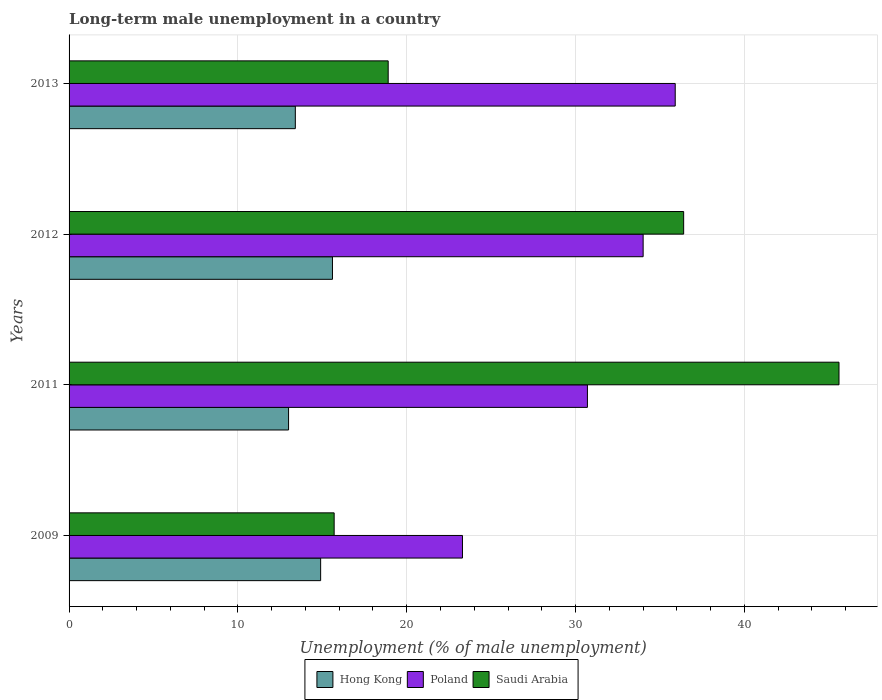How many groups of bars are there?
Your answer should be compact. 4. How many bars are there on the 2nd tick from the top?
Provide a succinct answer. 3. How many bars are there on the 3rd tick from the bottom?
Your response must be concise. 3. What is the label of the 2nd group of bars from the top?
Provide a succinct answer. 2012. In how many cases, is the number of bars for a given year not equal to the number of legend labels?
Your answer should be very brief. 0. What is the percentage of long-term unemployed male population in Poland in 2012?
Give a very brief answer. 34. Across all years, what is the maximum percentage of long-term unemployed male population in Poland?
Offer a very short reply. 35.9. Across all years, what is the minimum percentage of long-term unemployed male population in Poland?
Your answer should be compact. 23.3. In which year was the percentage of long-term unemployed male population in Saudi Arabia maximum?
Provide a short and direct response. 2011. What is the total percentage of long-term unemployed male population in Poland in the graph?
Your answer should be very brief. 123.9. What is the difference between the percentage of long-term unemployed male population in Hong Kong in 2009 and that in 2012?
Your response must be concise. -0.7. What is the difference between the percentage of long-term unemployed male population in Poland in 2009 and the percentage of long-term unemployed male population in Hong Kong in 2012?
Provide a short and direct response. 7.7. What is the average percentage of long-term unemployed male population in Poland per year?
Your answer should be compact. 30.98. In the year 2013, what is the difference between the percentage of long-term unemployed male population in Saudi Arabia and percentage of long-term unemployed male population in Poland?
Offer a very short reply. -17. In how many years, is the percentage of long-term unemployed male population in Poland greater than 6 %?
Offer a very short reply. 4. What is the ratio of the percentage of long-term unemployed male population in Saudi Arabia in 2009 to that in 2013?
Offer a terse response. 0.83. Is the percentage of long-term unemployed male population in Hong Kong in 2011 less than that in 2013?
Give a very brief answer. Yes. What is the difference between the highest and the second highest percentage of long-term unemployed male population in Saudi Arabia?
Keep it short and to the point. 9.2. What is the difference between the highest and the lowest percentage of long-term unemployed male population in Hong Kong?
Provide a short and direct response. 2.6. In how many years, is the percentage of long-term unemployed male population in Poland greater than the average percentage of long-term unemployed male population in Poland taken over all years?
Offer a terse response. 2. Is the sum of the percentage of long-term unemployed male population in Poland in 2009 and 2012 greater than the maximum percentage of long-term unemployed male population in Hong Kong across all years?
Your answer should be very brief. Yes. What does the 1st bar from the bottom in 2009 represents?
Offer a very short reply. Hong Kong. Is it the case that in every year, the sum of the percentage of long-term unemployed male population in Poland and percentage of long-term unemployed male population in Saudi Arabia is greater than the percentage of long-term unemployed male population in Hong Kong?
Offer a very short reply. Yes. How many years are there in the graph?
Offer a terse response. 4. How many legend labels are there?
Your response must be concise. 3. How are the legend labels stacked?
Provide a succinct answer. Horizontal. What is the title of the graph?
Keep it short and to the point. Long-term male unemployment in a country. What is the label or title of the X-axis?
Offer a terse response. Unemployment (% of male unemployment). What is the Unemployment (% of male unemployment) in Hong Kong in 2009?
Your answer should be very brief. 14.9. What is the Unemployment (% of male unemployment) in Poland in 2009?
Offer a terse response. 23.3. What is the Unemployment (% of male unemployment) of Saudi Arabia in 2009?
Your answer should be compact. 15.7. What is the Unemployment (% of male unemployment) in Poland in 2011?
Make the answer very short. 30.7. What is the Unemployment (% of male unemployment) of Saudi Arabia in 2011?
Your response must be concise. 45.6. What is the Unemployment (% of male unemployment) of Hong Kong in 2012?
Your response must be concise. 15.6. What is the Unemployment (% of male unemployment) of Saudi Arabia in 2012?
Make the answer very short. 36.4. What is the Unemployment (% of male unemployment) of Hong Kong in 2013?
Ensure brevity in your answer.  13.4. What is the Unemployment (% of male unemployment) in Poland in 2013?
Provide a short and direct response. 35.9. What is the Unemployment (% of male unemployment) in Saudi Arabia in 2013?
Your response must be concise. 18.9. Across all years, what is the maximum Unemployment (% of male unemployment) in Hong Kong?
Your answer should be compact. 15.6. Across all years, what is the maximum Unemployment (% of male unemployment) of Poland?
Provide a short and direct response. 35.9. Across all years, what is the maximum Unemployment (% of male unemployment) in Saudi Arabia?
Offer a terse response. 45.6. Across all years, what is the minimum Unemployment (% of male unemployment) in Hong Kong?
Your answer should be very brief. 13. Across all years, what is the minimum Unemployment (% of male unemployment) in Poland?
Your answer should be very brief. 23.3. Across all years, what is the minimum Unemployment (% of male unemployment) of Saudi Arabia?
Keep it short and to the point. 15.7. What is the total Unemployment (% of male unemployment) of Hong Kong in the graph?
Your response must be concise. 56.9. What is the total Unemployment (% of male unemployment) of Poland in the graph?
Your response must be concise. 123.9. What is the total Unemployment (% of male unemployment) in Saudi Arabia in the graph?
Your answer should be very brief. 116.6. What is the difference between the Unemployment (% of male unemployment) of Hong Kong in 2009 and that in 2011?
Give a very brief answer. 1.9. What is the difference between the Unemployment (% of male unemployment) in Poland in 2009 and that in 2011?
Provide a succinct answer. -7.4. What is the difference between the Unemployment (% of male unemployment) of Saudi Arabia in 2009 and that in 2011?
Offer a very short reply. -29.9. What is the difference between the Unemployment (% of male unemployment) in Hong Kong in 2009 and that in 2012?
Provide a succinct answer. -0.7. What is the difference between the Unemployment (% of male unemployment) in Poland in 2009 and that in 2012?
Offer a terse response. -10.7. What is the difference between the Unemployment (% of male unemployment) in Saudi Arabia in 2009 and that in 2012?
Offer a terse response. -20.7. What is the difference between the Unemployment (% of male unemployment) of Hong Kong in 2011 and that in 2012?
Offer a very short reply. -2.6. What is the difference between the Unemployment (% of male unemployment) of Saudi Arabia in 2011 and that in 2012?
Make the answer very short. 9.2. What is the difference between the Unemployment (% of male unemployment) of Saudi Arabia in 2011 and that in 2013?
Provide a short and direct response. 26.7. What is the difference between the Unemployment (% of male unemployment) in Hong Kong in 2012 and that in 2013?
Offer a terse response. 2.2. What is the difference between the Unemployment (% of male unemployment) in Poland in 2012 and that in 2013?
Keep it short and to the point. -1.9. What is the difference between the Unemployment (% of male unemployment) in Saudi Arabia in 2012 and that in 2013?
Your answer should be very brief. 17.5. What is the difference between the Unemployment (% of male unemployment) in Hong Kong in 2009 and the Unemployment (% of male unemployment) in Poland in 2011?
Give a very brief answer. -15.8. What is the difference between the Unemployment (% of male unemployment) in Hong Kong in 2009 and the Unemployment (% of male unemployment) in Saudi Arabia in 2011?
Offer a very short reply. -30.7. What is the difference between the Unemployment (% of male unemployment) in Poland in 2009 and the Unemployment (% of male unemployment) in Saudi Arabia in 2011?
Provide a short and direct response. -22.3. What is the difference between the Unemployment (% of male unemployment) of Hong Kong in 2009 and the Unemployment (% of male unemployment) of Poland in 2012?
Make the answer very short. -19.1. What is the difference between the Unemployment (% of male unemployment) in Hong Kong in 2009 and the Unemployment (% of male unemployment) in Saudi Arabia in 2012?
Provide a short and direct response. -21.5. What is the difference between the Unemployment (% of male unemployment) in Poland in 2009 and the Unemployment (% of male unemployment) in Saudi Arabia in 2012?
Offer a very short reply. -13.1. What is the difference between the Unemployment (% of male unemployment) in Hong Kong in 2009 and the Unemployment (% of male unemployment) in Poland in 2013?
Make the answer very short. -21. What is the difference between the Unemployment (% of male unemployment) of Hong Kong in 2009 and the Unemployment (% of male unemployment) of Saudi Arabia in 2013?
Provide a short and direct response. -4. What is the difference between the Unemployment (% of male unemployment) in Hong Kong in 2011 and the Unemployment (% of male unemployment) in Poland in 2012?
Provide a short and direct response. -21. What is the difference between the Unemployment (% of male unemployment) in Hong Kong in 2011 and the Unemployment (% of male unemployment) in Saudi Arabia in 2012?
Keep it short and to the point. -23.4. What is the difference between the Unemployment (% of male unemployment) in Hong Kong in 2011 and the Unemployment (% of male unemployment) in Poland in 2013?
Provide a short and direct response. -22.9. What is the difference between the Unemployment (% of male unemployment) of Hong Kong in 2011 and the Unemployment (% of male unemployment) of Saudi Arabia in 2013?
Keep it short and to the point. -5.9. What is the difference between the Unemployment (% of male unemployment) of Hong Kong in 2012 and the Unemployment (% of male unemployment) of Poland in 2013?
Offer a very short reply. -20.3. What is the difference between the Unemployment (% of male unemployment) of Hong Kong in 2012 and the Unemployment (% of male unemployment) of Saudi Arabia in 2013?
Your answer should be compact. -3.3. What is the difference between the Unemployment (% of male unemployment) in Poland in 2012 and the Unemployment (% of male unemployment) in Saudi Arabia in 2013?
Make the answer very short. 15.1. What is the average Unemployment (% of male unemployment) of Hong Kong per year?
Your answer should be very brief. 14.22. What is the average Unemployment (% of male unemployment) of Poland per year?
Offer a terse response. 30.98. What is the average Unemployment (% of male unemployment) in Saudi Arabia per year?
Your answer should be compact. 29.15. In the year 2009, what is the difference between the Unemployment (% of male unemployment) of Poland and Unemployment (% of male unemployment) of Saudi Arabia?
Offer a terse response. 7.6. In the year 2011, what is the difference between the Unemployment (% of male unemployment) of Hong Kong and Unemployment (% of male unemployment) of Poland?
Your answer should be compact. -17.7. In the year 2011, what is the difference between the Unemployment (% of male unemployment) in Hong Kong and Unemployment (% of male unemployment) in Saudi Arabia?
Offer a terse response. -32.6. In the year 2011, what is the difference between the Unemployment (% of male unemployment) in Poland and Unemployment (% of male unemployment) in Saudi Arabia?
Make the answer very short. -14.9. In the year 2012, what is the difference between the Unemployment (% of male unemployment) in Hong Kong and Unemployment (% of male unemployment) in Poland?
Provide a succinct answer. -18.4. In the year 2012, what is the difference between the Unemployment (% of male unemployment) in Hong Kong and Unemployment (% of male unemployment) in Saudi Arabia?
Ensure brevity in your answer.  -20.8. In the year 2013, what is the difference between the Unemployment (% of male unemployment) of Hong Kong and Unemployment (% of male unemployment) of Poland?
Provide a succinct answer. -22.5. In the year 2013, what is the difference between the Unemployment (% of male unemployment) of Poland and Unemployment (% of male unemployment) of Saudi Arabia?
Make the answer very short. 17. What is the ratio of the Unemployment (% of male unemployment) of Hong Kong in 2009 to that in 2011?
Keep it short and to the point. 1.15. What is the ratio of the Unemployment (% of male unemployment) of Poland in 2009 to that in 2011?
Your response must be concise. 0.76. What is the ratio of the Unemployment (% of male unemployment) of Saudi Arabia in 2009 to that in 2011?
Give a very brief answer. 0.34. What is the ratio of the Unemployment (% of male unemployment) in Hong Kong in 2009 to that in 2012?
Offer a terse response. 0.96. What is the ratio of the Unemployment (% of male unemployment) in Poland in 2009 to that in 2012?
Give a very brief answer. 0.69. What is the ratio of the Unemployment (% of male unemployment) of Saudi Arabia in 2009 to that in 2012?
Your response must be concise. 0.43. What is the ratio of the Unemployment (% of male unemployment) of Hong Kong in 2009 to that in 2013?
Ensure brevity in your answer.  1.11. What is the ratio of the Unemployment (% of male unemployment) of Poland in 2009 to that in 2013?
Your response must be concise. 0.65. What is the ratio of the Unemployment (% of male unemployment) of Saudi Arabia in 2009 to that in 2013?
Provide a short and direct response. 0.83. What is the ratio of the Unemployment (% of male unemployment) of Poland in 2011 to that in 2012?
Provide a succinct answer. 0.9. What is the ratio of the Unemployment (% of male unemployment) in Saudi Arabia in 2011 to that in 2012?
Your answer should be compact. 1.25. What is the ratio of the Unemployment (% of male unemployment) in Hong Kong in 2011 to that in 2013?
Ensure brevity in your answer.  0.97. What is the ratio of the Unemployment (% of male unemployment) of Poland in 2011 to that in 2013?
Offer a terse response. 0.86. What is the ratio of the Unemployment (% of male unemployment) of Saudi Arabia in 2011 to that in 2013?
Your answer should be very brief. 2.41. What is the ratio of the Unemployment (% of male unemployment) in Hong Kong in 2012 to that in 2013?
Your answer should be compact. 1.16. What is the ratio of the Unemployment (% of male unemployment) of Poland in 2012 to that in 2013?
Provide a succinct answer. 0.95. What is the ratio of the Unemployment (% of male unemployment) of Saudi Arabia in 2012 to that in 2013?
Keep it short and to the point. 1.93. What is the difference between the highest and the second highest Unemployment (% of male unemployment) of Hong Kong?
Keep it short and to the point. 0.7. What is the difference between the highest and the second highest Unemployment (% of male unemployment) of Poland?
Offer a terse response. 1.9. What is the difference between the highest and the second highest Unemployment (% of male unemployment) of Saudi Arabia?
Your answer should be very brief. 9.2. What is the difference between the highest and the lowest Unemployment (% of male unemployment) in Hong Kong?
Your response must be concise. 2.6. What is the difference between the highest and the lowest Unemployment (% of male unemployment) in Poland?
Give a very brief answer. 12.6. What is the difference between the highest and the lowest Unemployment (% of male unemployment) in Saudi Arabia?
Offer a very short reply. 29.9. 